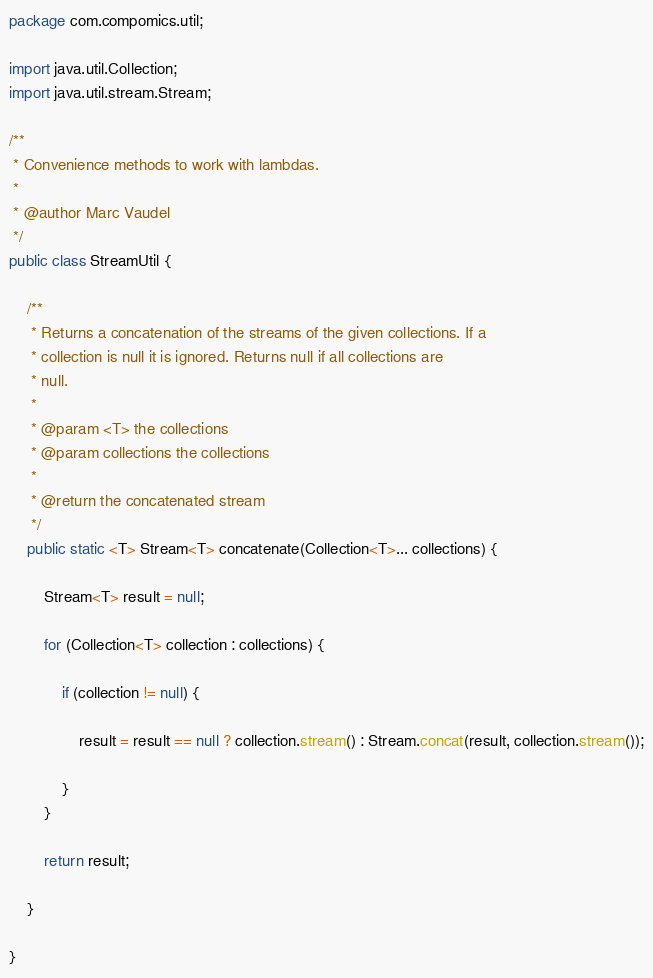<code> <loc_0><loc_0><loc_500><loc_500><_Java_>package com.compomics.util;

import java.util.Collection;
import java.util.stream.Stream;

/**
 * Convenience methods to work with lambdas.
 *
 * @author Marc Vaudel
 */
public class StreamUtil {

    /**
     * Returns a concatenation of the streams of the given collections. If a
     * collection is null it is ignored. Returns null if all collections are
     * null.
     *
     * @param <T> the collections
     * @param collections the collections
     *
     * @return the concatenated stream
     */
    public static <T> Stream<T> concatenate(Collection<T>... collections) {

        Stream<T> result = null;

        for (Collection<T> collection : collections) {

            if (collection != null) {

                result = result == null ? collection.stream() : Stream.concat(result, collection.stream());

            }
        }

        return result;

    }

}
</code> 